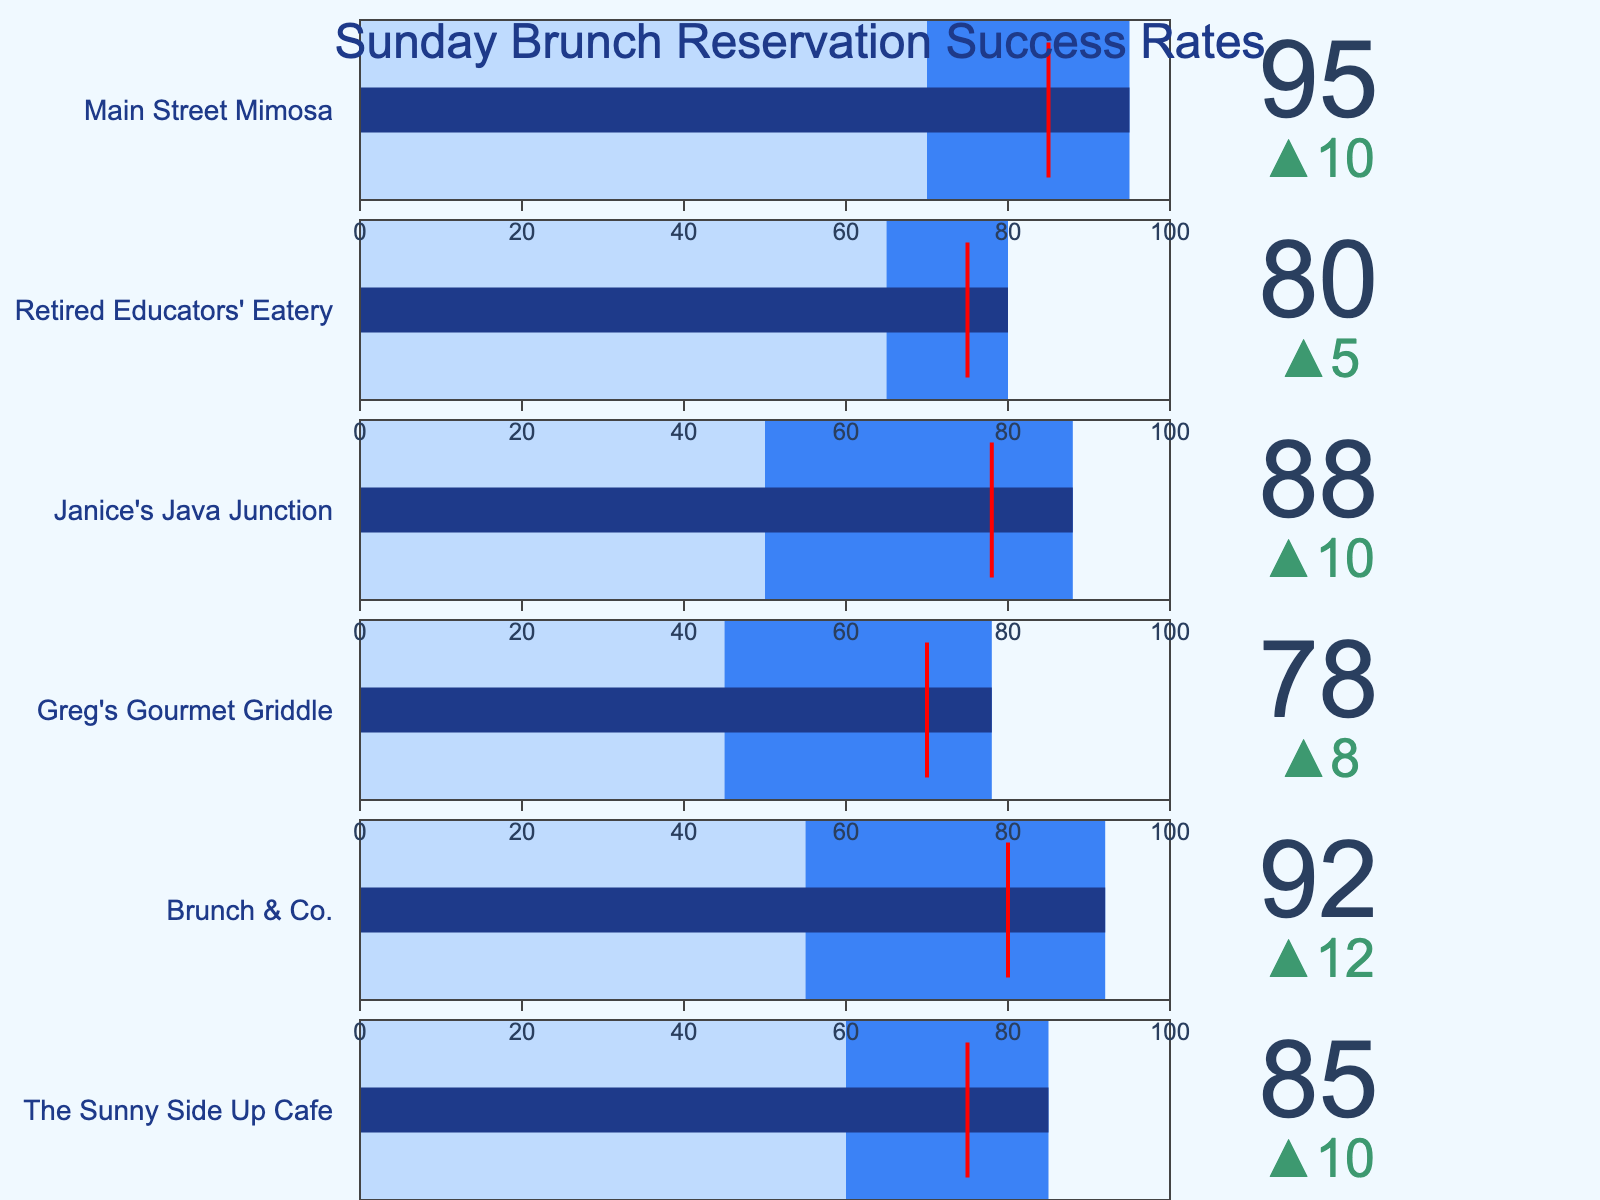How many restaurants are shown in the figure? The figure lists several restaurants, with each one occupying a horizontal band. Counting each band gives the total number of restaurants displayed. There are 6 restaurants listed.
Answer: 6 What is the highest Sunday reservation success rate among the restaurants? By examining the Sunday values in each band, Main Street Mimosa shows the highest number at 95.
Answer: 95 Which restaurant has the largest difference between their target and Sunday reservation success rate? The differences between the target and Sunday values can be calculated and compared: The Sunny Side Up Cafe (85-75=10), Brunch & Co. (92-80=12), Greg's Gourmet Griddle (78-70=8), Janice's Java Junction (88-78=10), Retired Educators' Eatery (80-75=5), Main Street Mimosa (95-85=10). The largest difference is at Brunch & Co.
Answer: Brunch & Co Which restaurant succeeded best at hitting their target for Sunday reservations? The success rate can be determined by examining how close the Sunday value is to the target. Main Street Mimosa is closest to its target within 10 units (95 vs. 85).
Answer: Main Street Mimosa What is the average weekday success rate across all restaurants? Adding all weekday values (60, 55, 45, 50, 65, 70) and dividing by the number of restaurants (6), the average is (60+55+45+50+65+70)/6 = 57.5
Answer: 57.5 Which restaurant has the lowest weekday reservation success rate? Reviewing the weekday values for each restaurant, Greg's Gourmet Griddle has the lowest value at 45.
Answer: Greg's Gourmet Griddle Compare the Sunday and weekday success rates for The Sunny Side Up Cafe. Which one is higher? The Sunny Side Up Cafe has a Sunday rate of 85 and a weekday rate of 60. Sunday is higher.
Answer: Sunday Which restaurant has the smallest difference between their weekday and Sunday success rates? The differences between weekday and Sunday values are calculated for all restaurants, and the smallest difference is found: The Sunny Side Up Cafe (85-60=25), Brunch & Co. (92-55=37), Greg's Gourmet Griddle (78-45=33), Janice's Java Junction (88-50=38), Retired Educators' Eatery (80-65=15), Main Street Mimosa (95-70=25). The Retired Educators' Eatery has the smallest difference.
Answer: Retired Educators' Eatery How does the Sunday success rate for Brunch & Co. compare to its target? The Sunday rate for Brunch & Co. is 92, while the target is 80. The Sunday success rate exceeds the target by 12 units.
Answer: Over the target by 12 Are there any restaurants where the Sunday success rate is below the weekday rate? Comparing Sunday and weekday values for all restaurants, none show a lower Sunday rate than the weekday rate, as every Sunday rate is higher.
Answer: No 